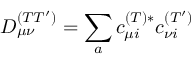Convert formula to latex. <formula><loc_0><loc_0><loc_500><loc_500>D _ { \mu \nu } ^ { ( T T ^ { \prime } ) } = \sum _ { a } c _ { \mu i } ^ { ( T ) * } c _ { \nu i } ^ { ( T ^ { \prime } ) }</formula> 